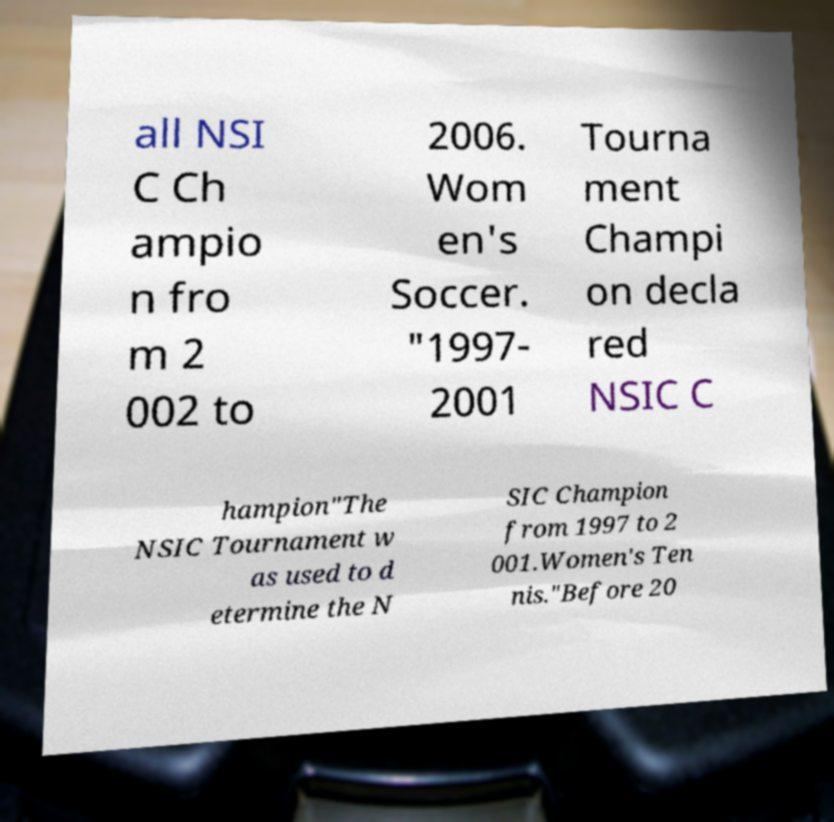Could you assist in decoding the text presented in this image and type it out clearly? all NSI C Ch ampio n fro m 2 002 to 2006. Wom en's Soccer. "1997- 2001 Tourna ment Champi on decla red NSIC C hampion"The NSIC Tournament w as used to d etermine the N SIC Champion from 1997 to 2 001.Women's Ten nis."Before 20 